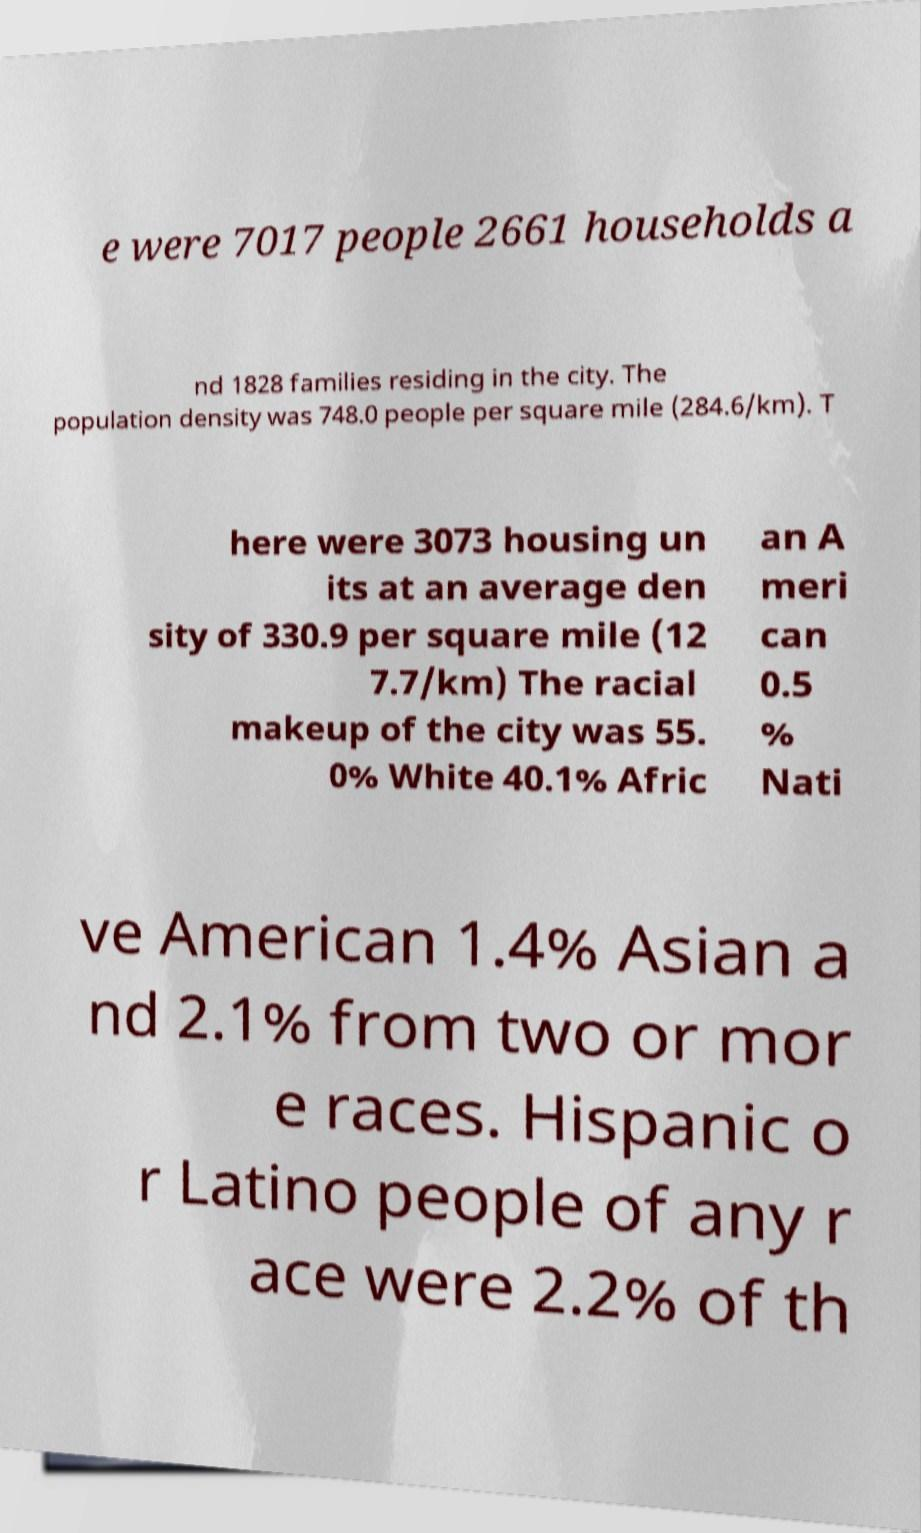Could you assist in decoding the text presented in this image and type it out clearly? e were 7017 people 2661 households a nd 1828 families residing in the city. The population density was 748.0 people per square mile (284.6/km). T here were 3073 housing un its at an average den sity of 330.9 per square mile (12 7.7/km) The racial makeup of the city was 55. 0% White 40.1% Afric an A meri can 0.5 % Nati ve American 1.4% Asian a nd 2.1% from two or mor e races. Hispanic o r Latino people of any r ace were 2.2% of th 